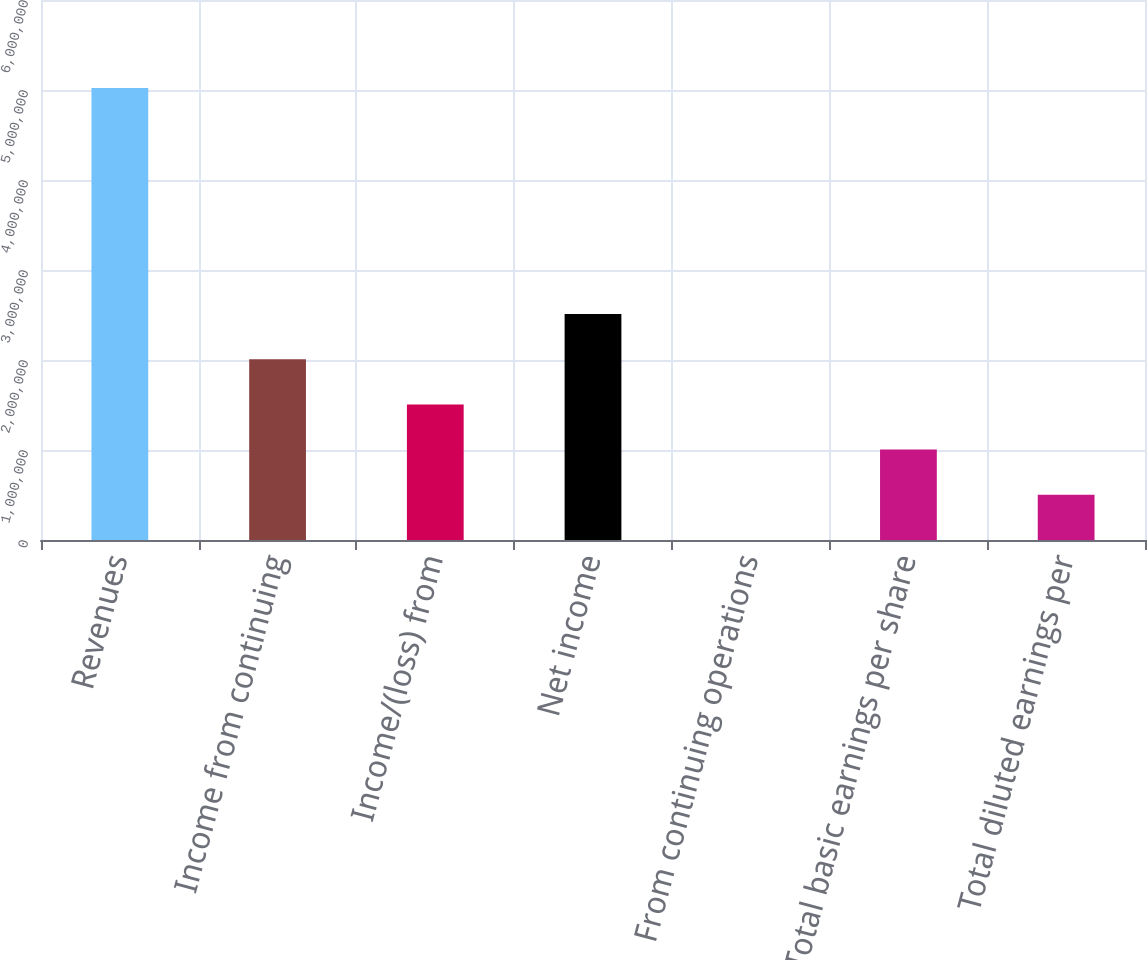<chart> <loc_0><loc_0><loc_500><loc_500><bar_chart><fcel>Revenues<fcel>Income from continuing<fcel>Income/(loss) from<fcel>Net income<fcel>From continuing operations<fcel>Total basic earnings per share<fcel>Total diluted earnings per<nl><fcel>5.02242e+06<fcel>2.00897e+06<fcel>1.50673e+06<fcel>2.51121e+06<fcel>3.81<fcel>1.00449e+06<fcel>502245<nl></chart> 